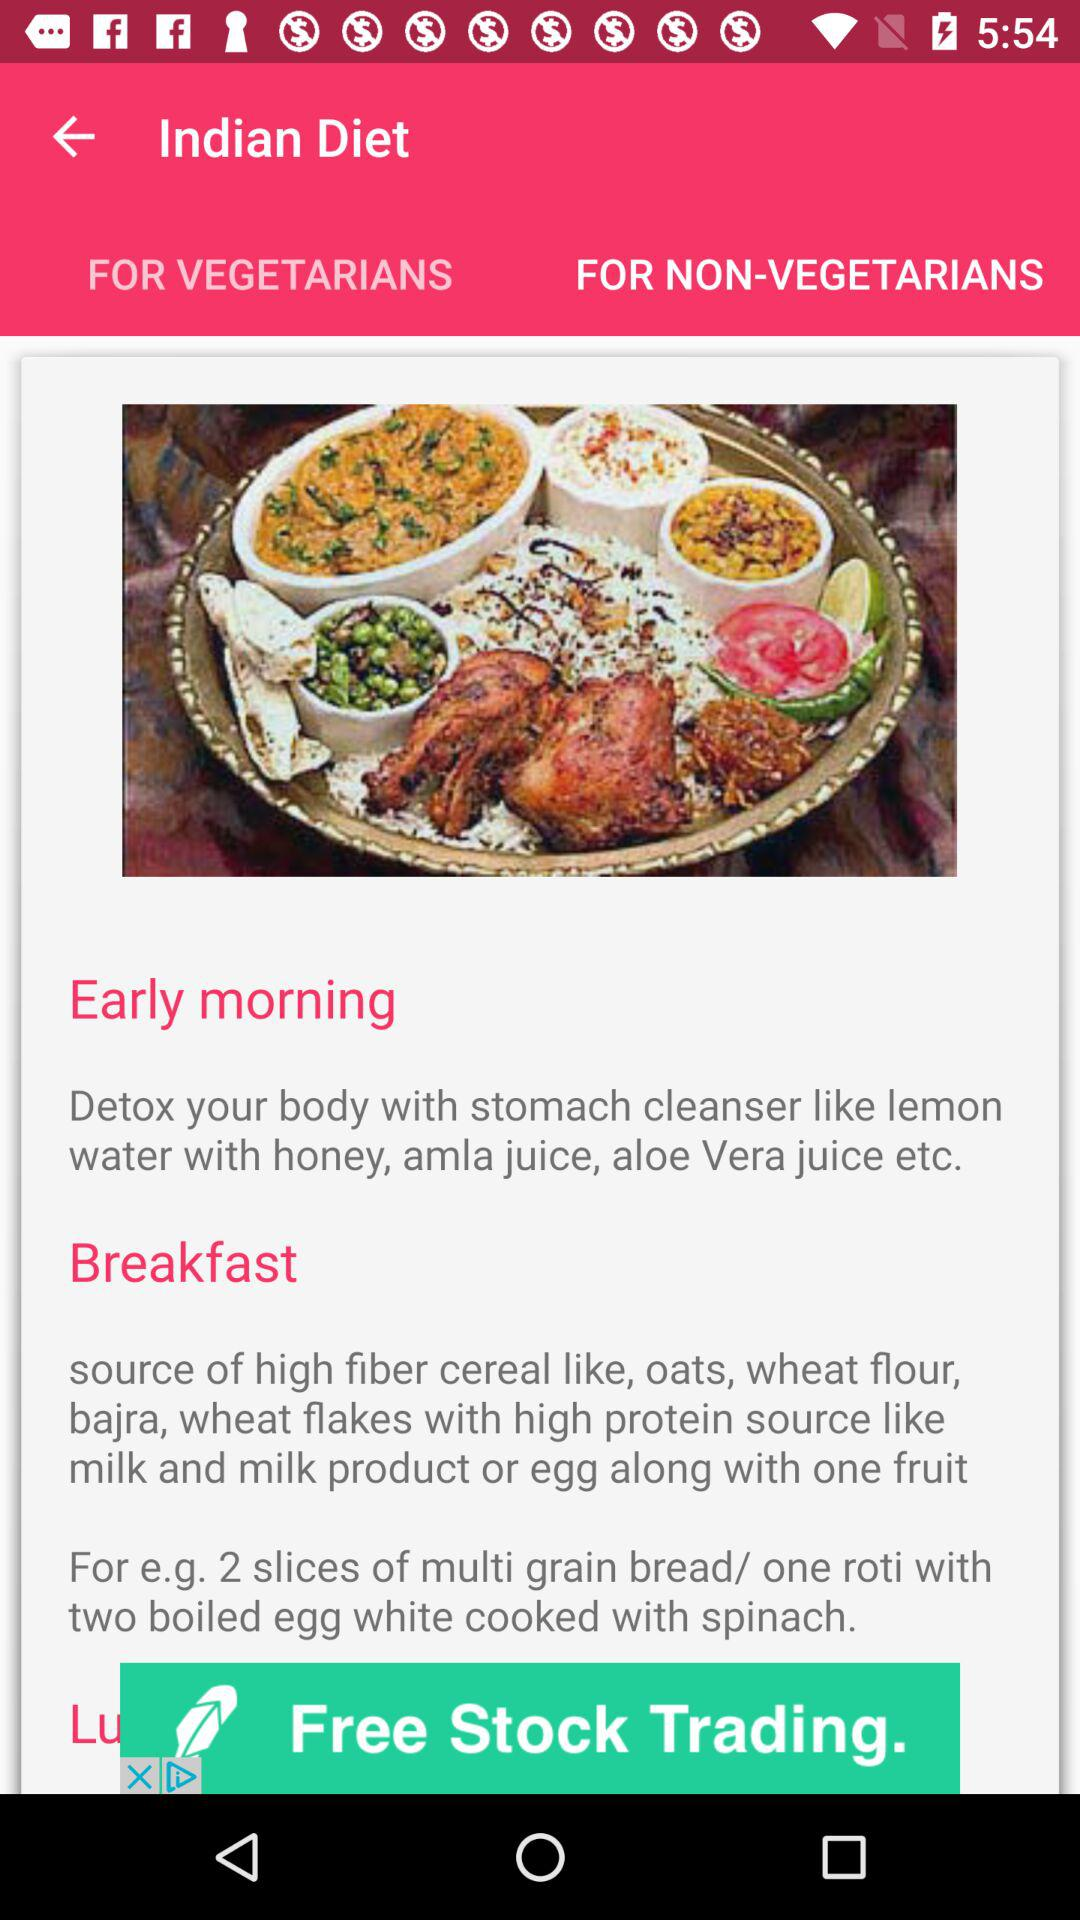What are the high protein source items? The high protein source items are milk and milk products, eggs and fruit. 